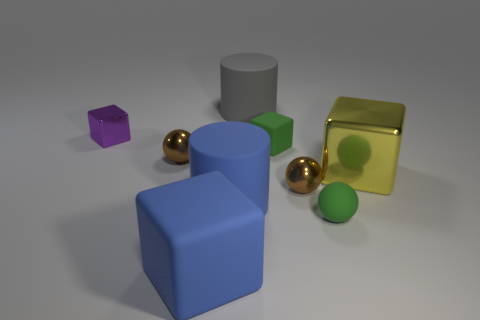What is the color of the shiny block that is the same size as the rubber ball? The shiny block that matches the size of the rubber ball is a lustrous gold color, exhibiting reflective properties that play with the light and give it a rich, vibrant appearance. 